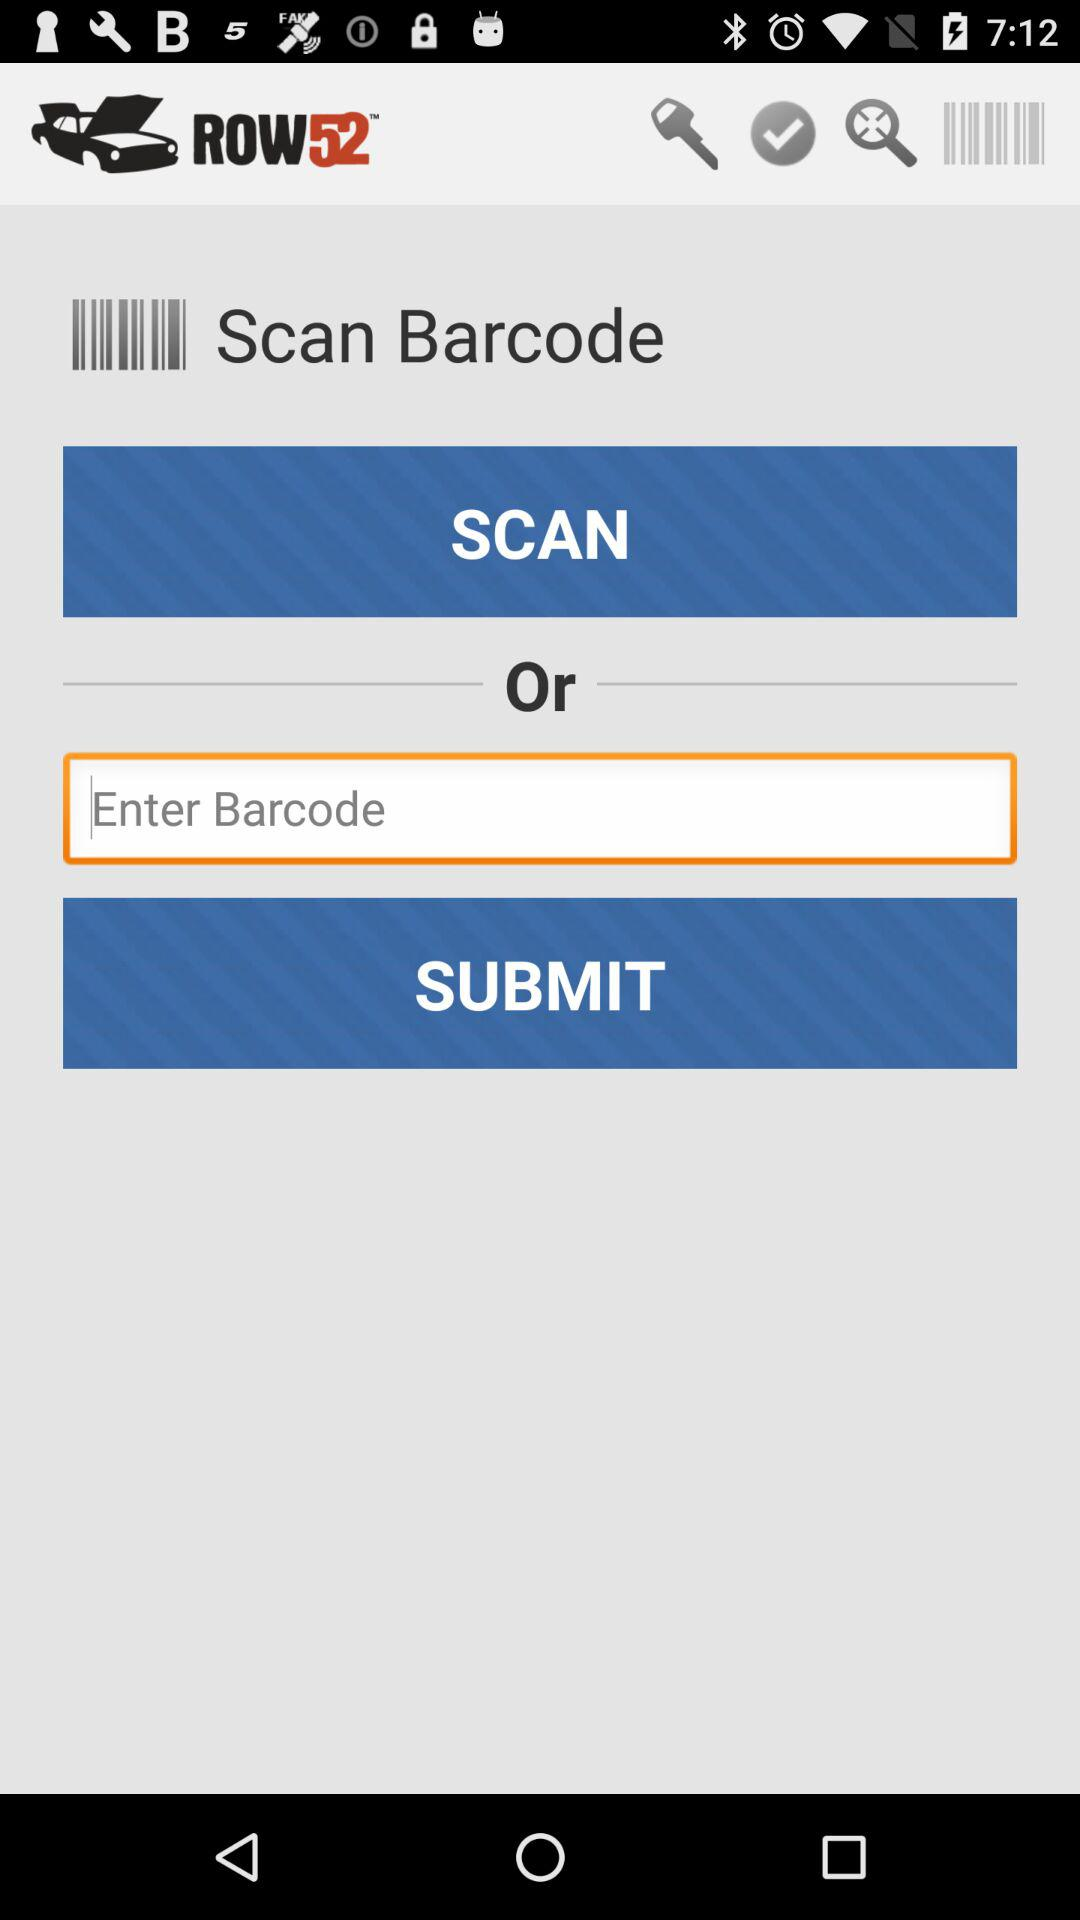What is the name of the application? The name of the application is "ROW52". 